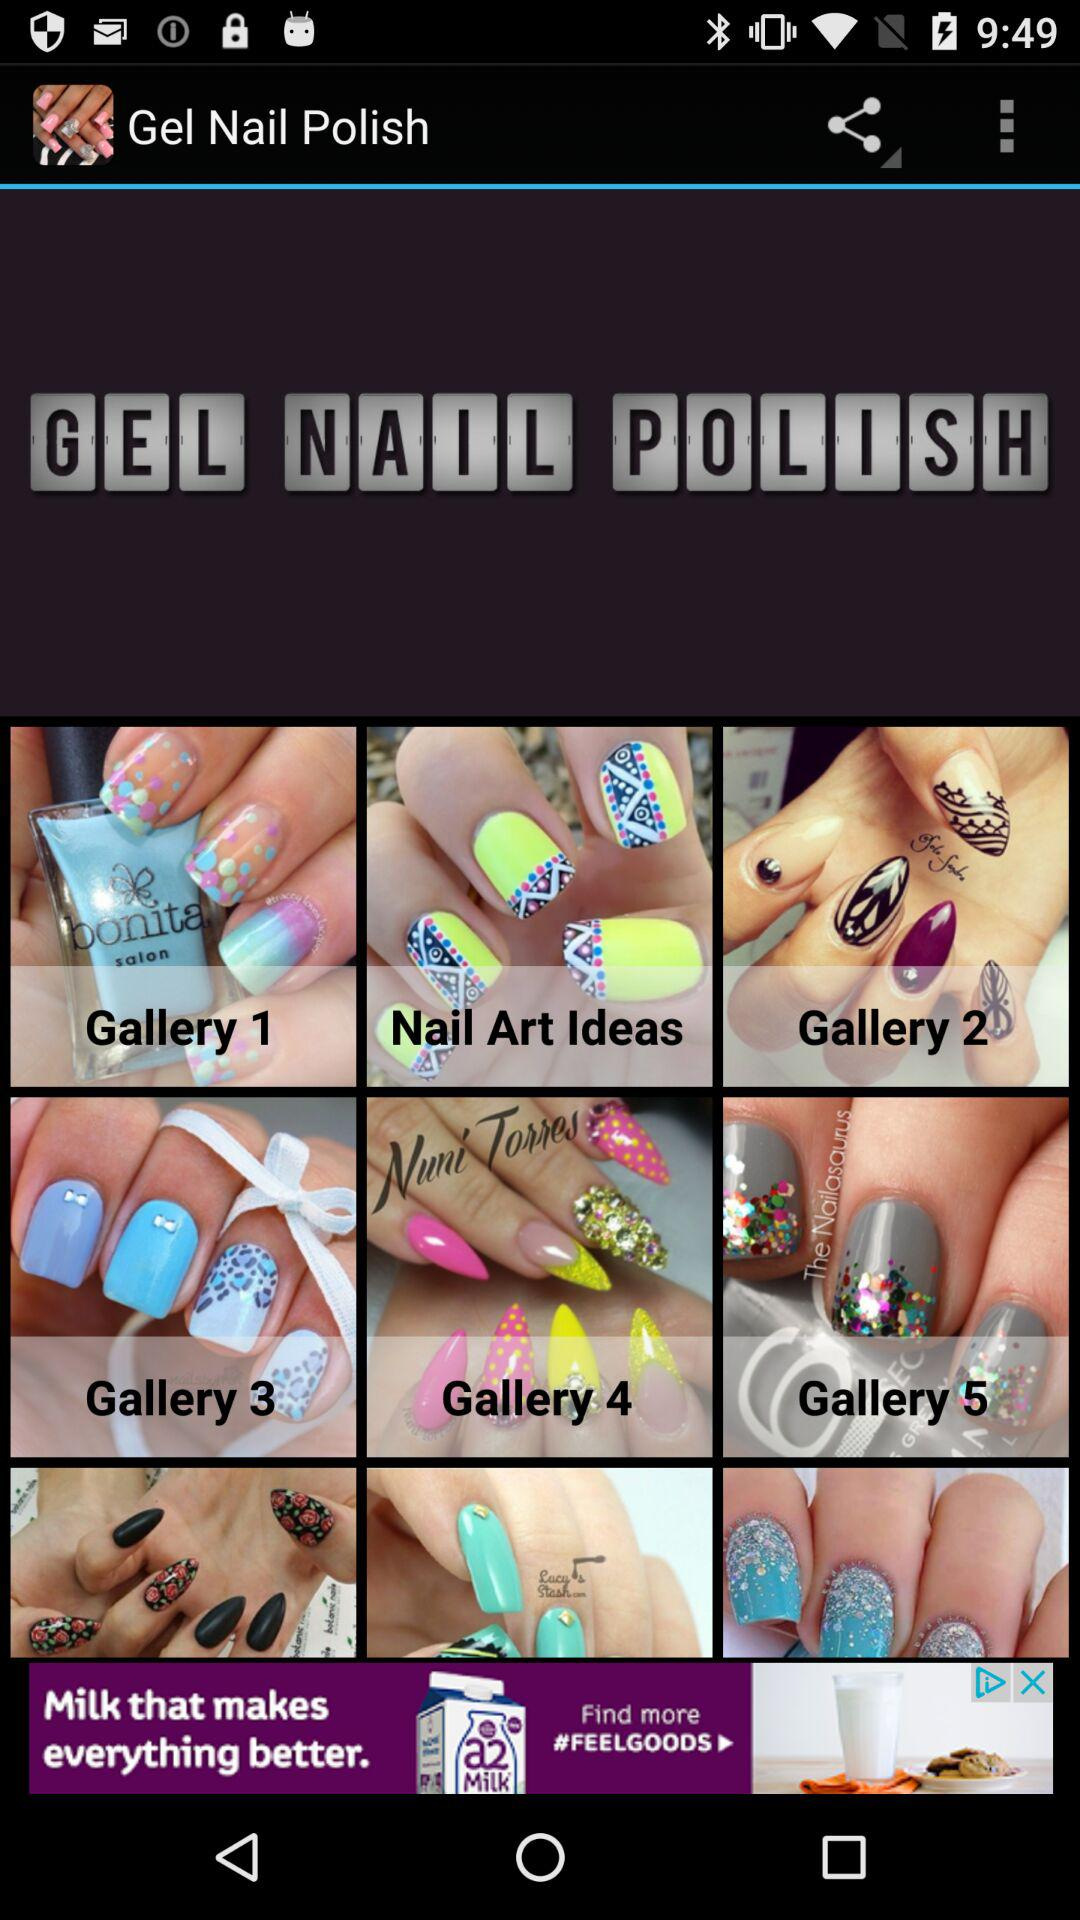How many galleries are there in the Gel Nail Polish app?
Answer the question using a single word or phrase. 5 